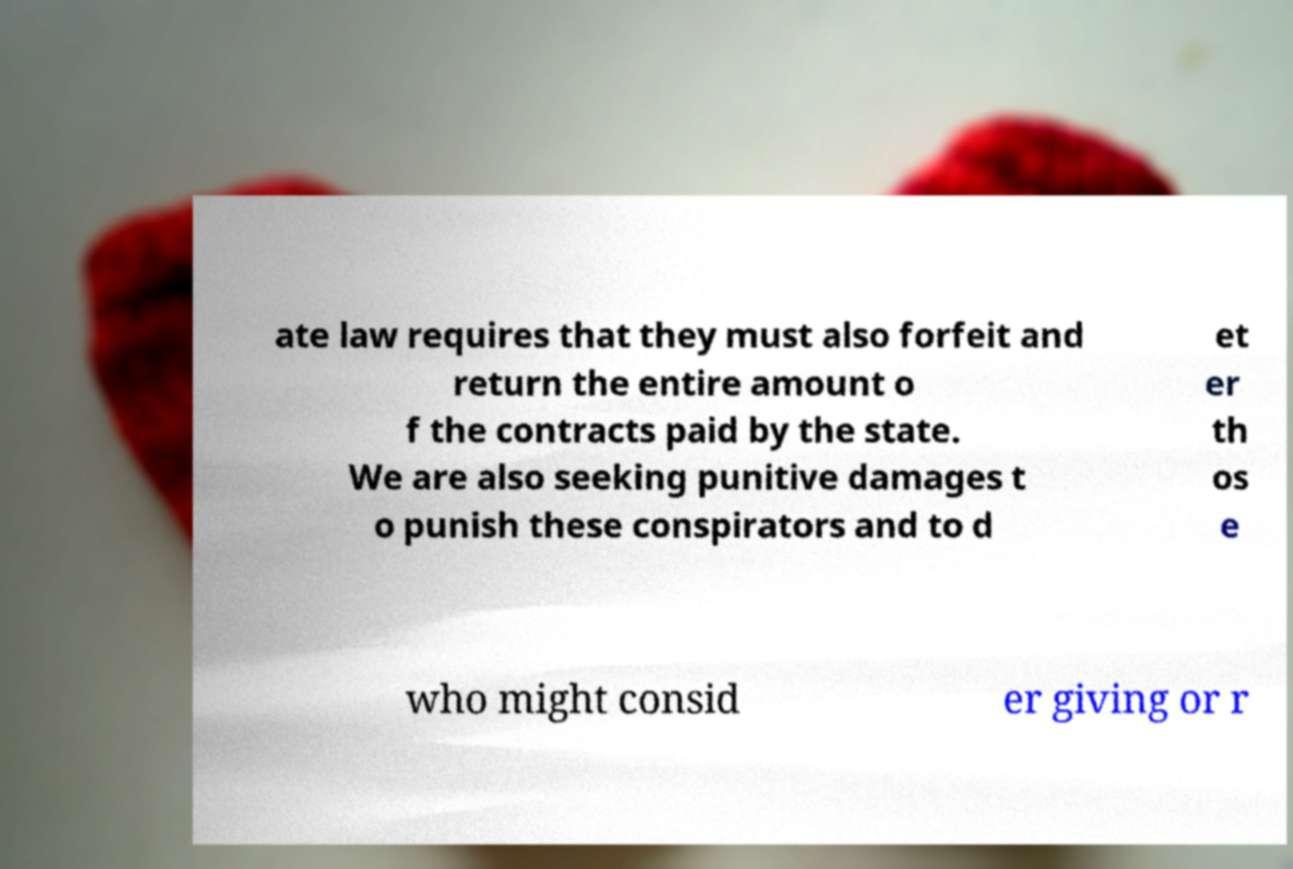There's text embedded in this image that I need extracted. Can you transcribe it verbatim? ate law requires that they must also forfeit and return the entire amount o f the contracts paid by the state. We are also seeking punitive damages t o punish these conspirators and to d et er th os e who might consid er giving or r 